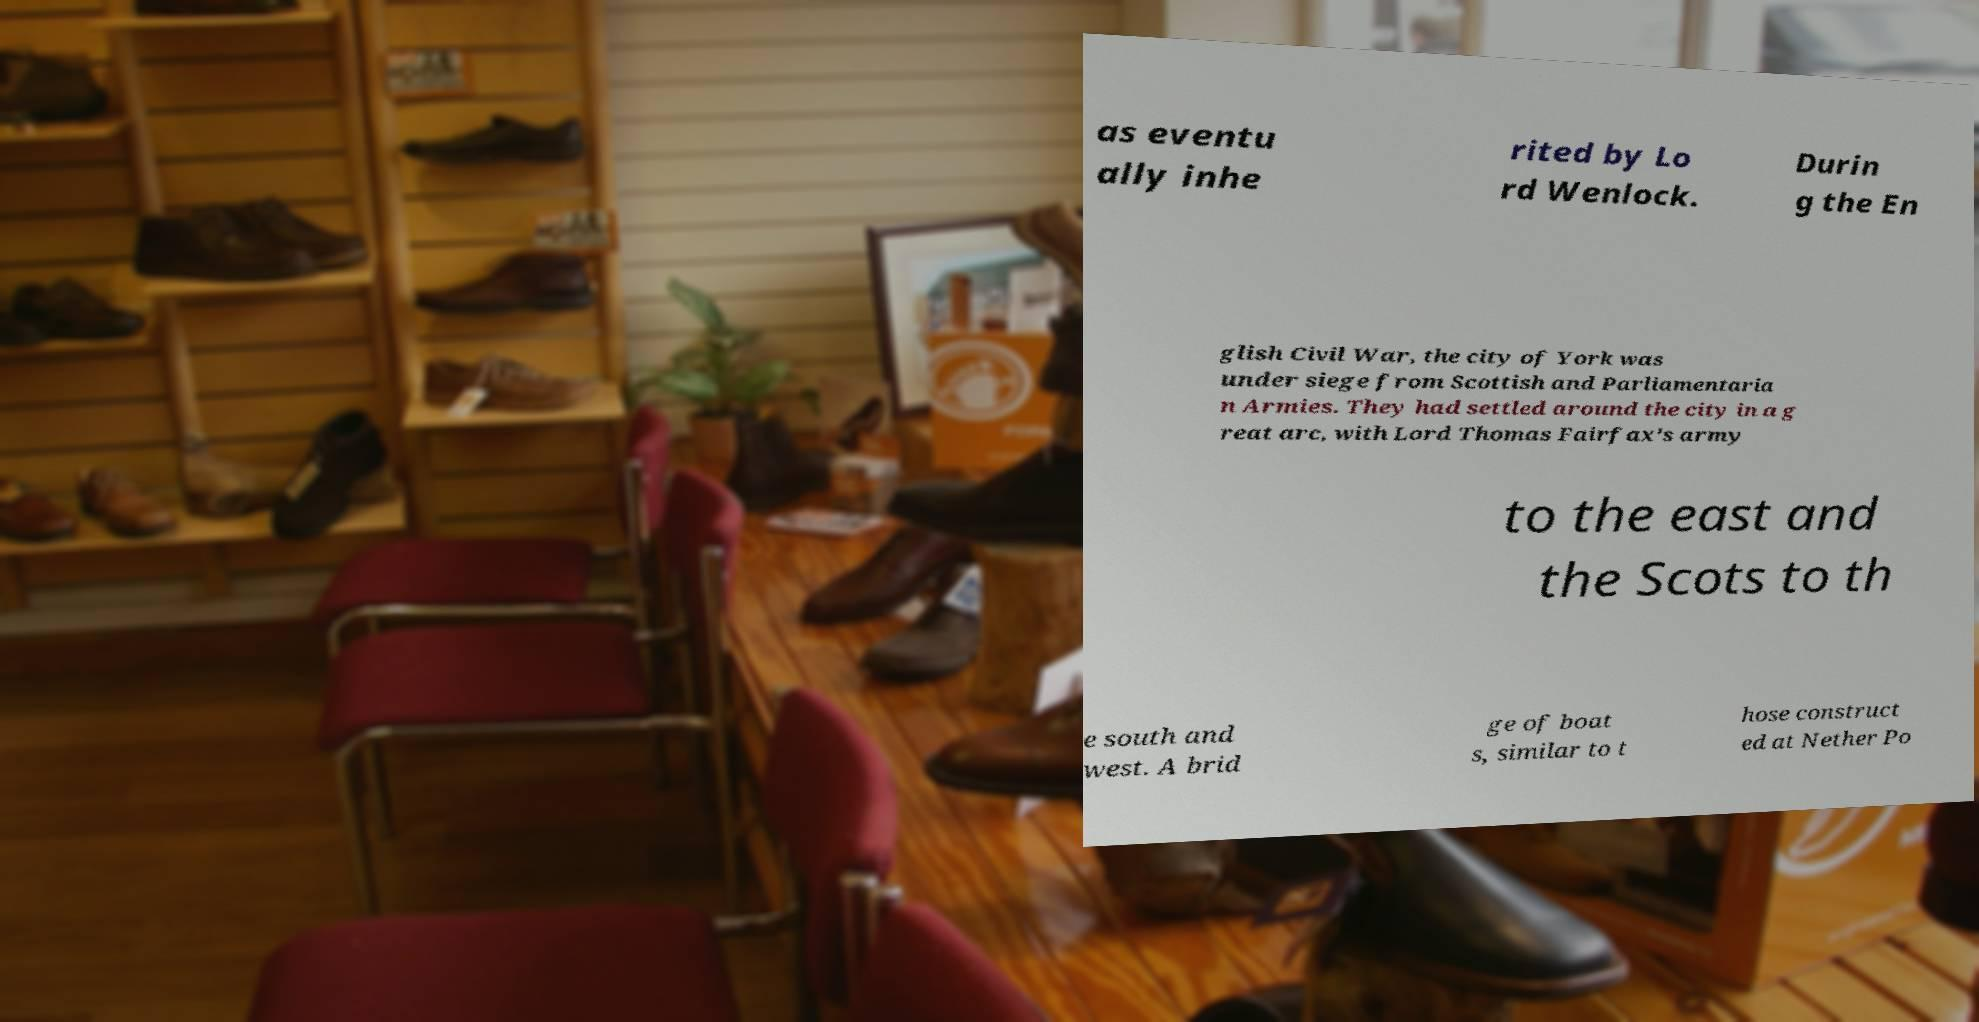There's text embedded in this image that I need extracted. Can you transcribe it verbatim? as eventu ally inhe rited by Lo rd Wenlock. Durin g the En glish Civil War, the city of York was under siege from Scottish and Parliamentaria n Armies. They had settled around the city in a g reat arc, with Lord Thomas Fairfax's army to the east and the Scots to th e south and west. A brid ge of boat s, similar to t hose construct ed at Nether Po 